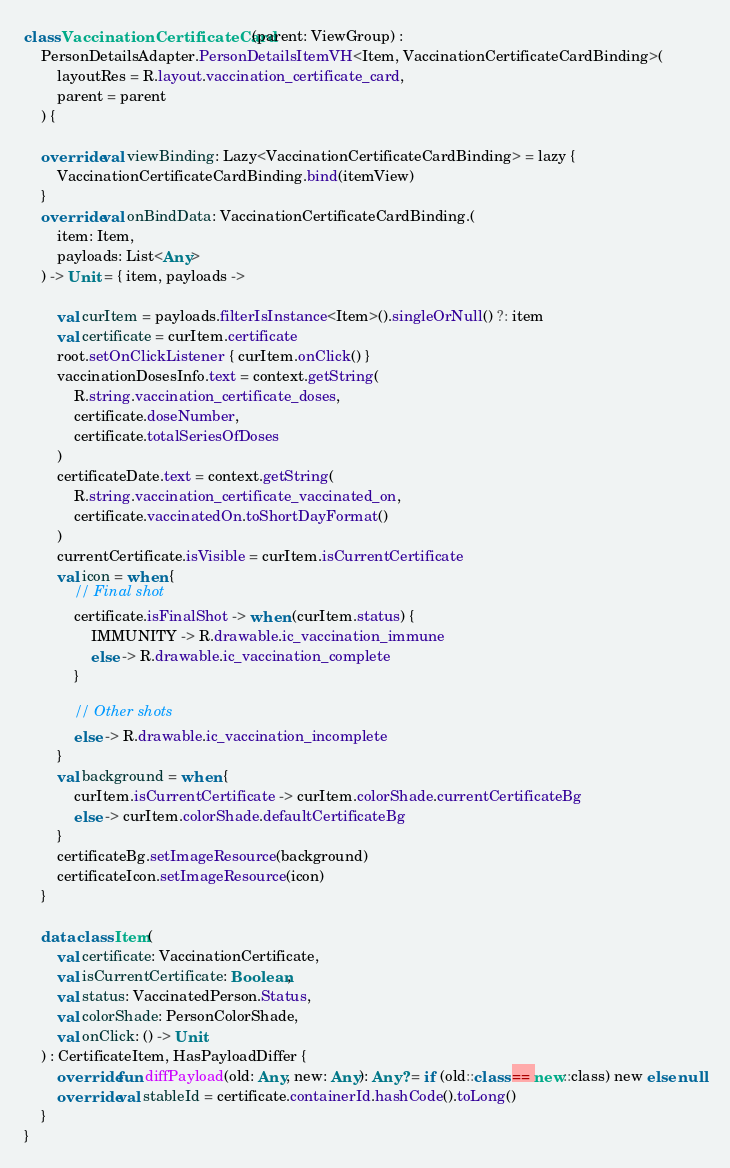Convert code to text. <code><loc_0><loc_0><loc_500><loc_500><_Kotlin_>class VaccinationCertificateCard(parent: ViewGroup) :
    PersonDetailsAdapter.PersonDetailsItemVH<Item, VaccinationCertificateCardBinding>(
        layoutRes = R.layout.vaccination_certificate_card,
        parent = parent
    ) {

    override val viewBinding: Lazy<VaccinationCertificateCardBinding> = lazy {
        VaccinationCertificateCardBinding.bind(itemView)
    }
    override val onBindData: VaccinationCertificateCardBinding.(
        item: Item,
        payloads: List<Any>
    ) -> Unit = { item, payloads ->

        val curItem = payloads.filterIsInstance<Item>().singleOrNull() ?: item
        val certificate = curItem.certificate
        root.setOnClickListener { curItem.onClick() }
        vaccinationDosesInfo.text = context.getString(
            R.string.vaccination_certificate_doses,
            certificate.doseNumber,
            certificate.totalSeriesOfDoses
        )
        certificateDate.text = context.getString(
            R.string.vaccination_certificate_vaccinated_on,
            certificate.vaccinatedOn.toShortDayFormat()
        )
        currentCertificate.isVisible = curItem.isCurrentCertificate
        val icon = when {
            // Final shot
            certificate.isFinalShot -> when (curItem.status) {
                IMMUNITY -> R.drawable.ic_vaccination_immune
                else -> R.drawable.ic_vaccination_complete
            }

            // Other shots
            else -> R.drawable.ic_vaccination_incomplete
        }
        val background = when {
            curItem.isCurrentCertificate -> curItem.colorShade.currentCertificateBg
            else -> curItem.colorShade.defaultCertificateBg
        }
        certificateBg.setImageResource(background)
        certificateIcon.setImageResource(icon)
    }

    data class Item(
        val certificate: VaccinationCertificate,
        val isCurrentCertificate: Boolean,
        val status: VaccinatedPerson.Status,
        val colorShade: PersonColorShade,
        val onClick: () -> Unit
    ) : CertificateItem, HasPayloadDiffer {
        override fun diffPayload(old: Any, new: Any): Any? = if (old::class == new::class) new else null
        override val stableId = certificate.containerId.hashCode().toLong()
    }
}
</code> 